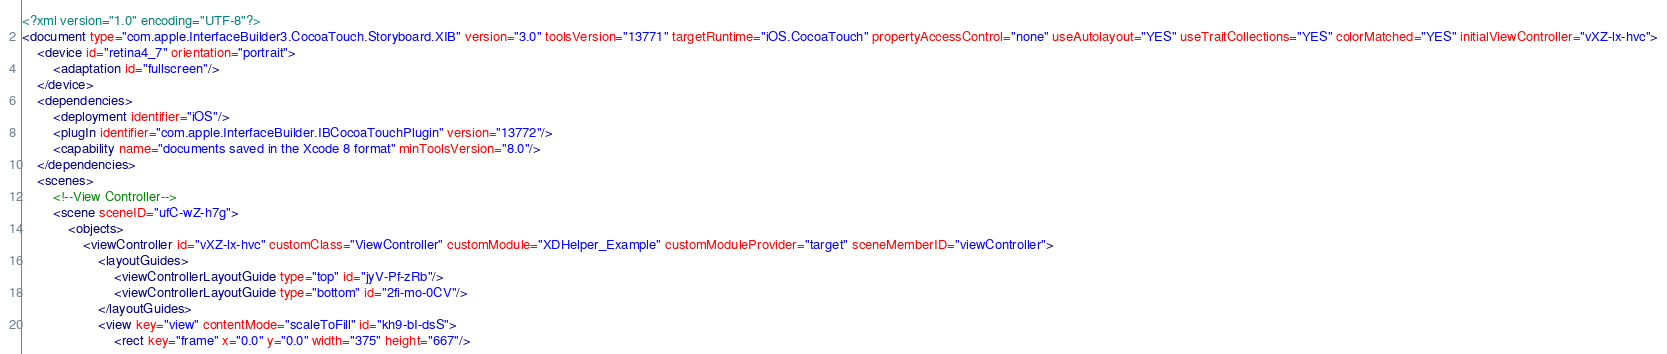<code> <loc_0><loc_0><loc_500><loc_500><_XML_><?xml version="1.0" encoding="UTF-8"?>
<document type="com.apple.InterfaceBuilder3.CocoaTouch.Storyboard.XIB" version="3.0" toolsVersion="13771" targetRuntime="iOS.CocoaTouch" propertyAccessControl="none" useAutolayout="YES" useTraitCollections="YES" colorMatched="YES" initialViewController="vXZ-lx-hvc">
    <device id="retina4_7" orientation="portrait">
        <adaptation id="fullscreen"/>
    </device>
    <dependencies>
        <deployment identifier="iOS"/>
        <plugIn identifier="com.apple.InterfaceBuilder.IBCocoaTouchPlugin" version="13772"/>
        <capability name="documents saved in the Xcode 8 format" minToolsVersion="8.0"/>
    </dependencies>
    <scenes>
        <!--View Controller-->
        <scene sceneID="ufC-wZ-h7g">
            <objects>
                <viewController id="vXZ-lx-hvc" customClass="ViewController" customModule="XDHelper_Example" customModuleProvider="target" sceneMemberID="viewController">
                    <layoutGuides>
                        <viewControllerLayoutGuide type="top" id="jyV-Pf-zRb"/>
                        <viewControllerLayoutGuide type="bottom" id="2fi-mo-0CV"/>
                    </layoutGuides>
                    <view key="view" contentMode="scaleToFill" id="kh9-bI-dsS">
                        <rect key="frame" x="0.0" y="0.0" width="375" height="667"/></code> 